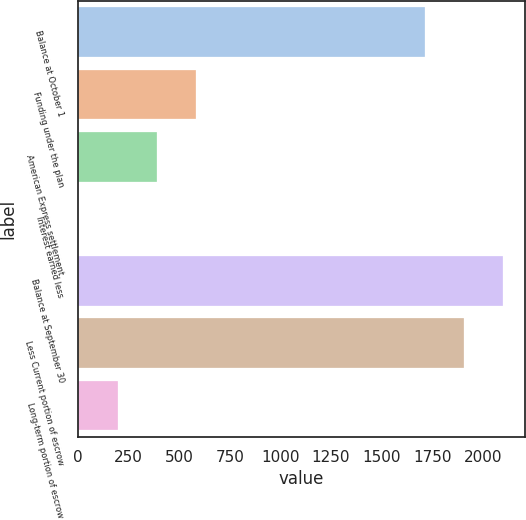Convert chart. <chart><loc_0><loc_0><loc_500><loc_500><bar_chart><fcel>Balance at October 1<fcel>Funding under the plan<fcel>American Express settlement<fcel>Interest earned less<fcel>Balance at September 30<fcel>Less Current portion of escrow<fcel>Long-term portion of escrow<nl><fcel>1715<fcel>581.5<fcel>388<fcel>1<fcel>2102<fcel>1908.5<fcel>194.5<nl></chart> 